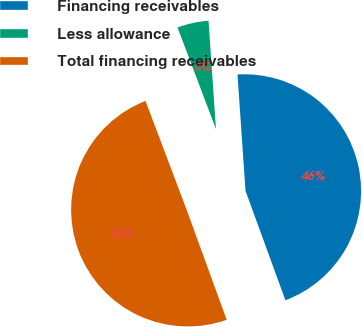Convert chart. <chart><loc_0><loc_0><loc_500><loc_500><pie_chart><fcel>Financing receivables<fcel>Less allowance<fcel>Total financing receivables<nl><fcel>45.53%<fcel>4.66%<fcel>49.81%<nl></chart> 